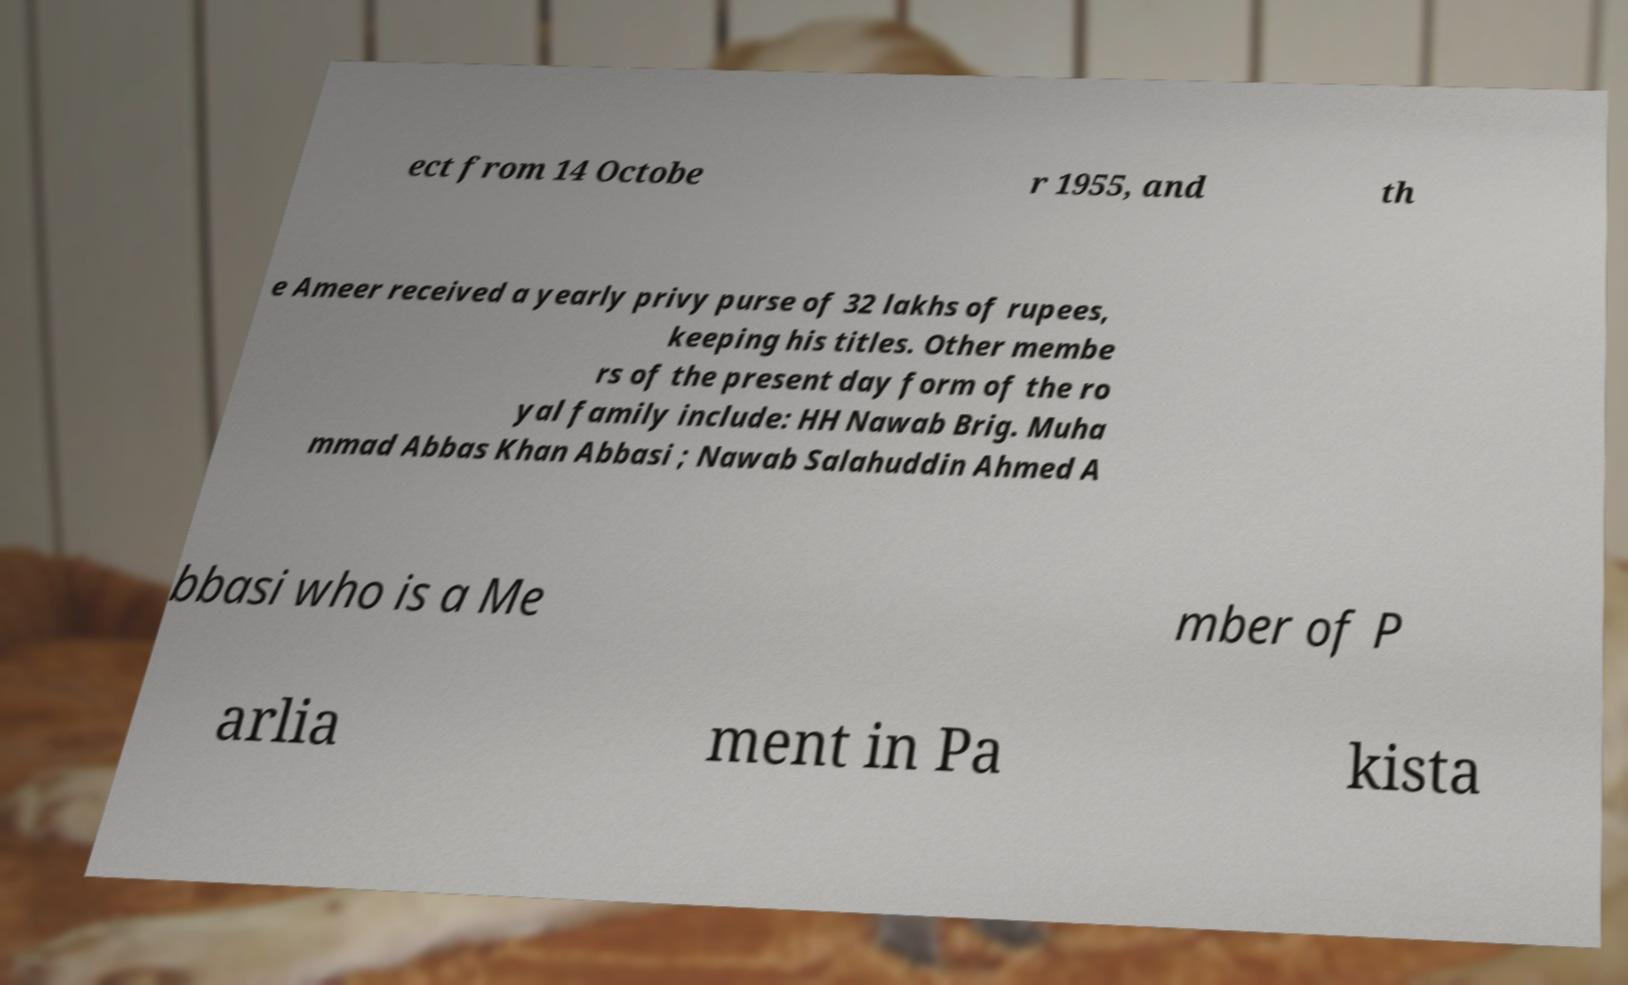Please identify and transcribe the text found in this image. ect from 14 Octobe r 1955, and th e Ameer received a yearly privy purse of 32 lakhs of rupees, keeping his titles. Other membe rs of the present day form of the ro yal family include: HH Nawab Brig. Muha mmad Abbas Khan Abbasi ; Nawab Salahuddin Ahmed A bbasi who is a Me mber of P arlia ment in Pa kista 